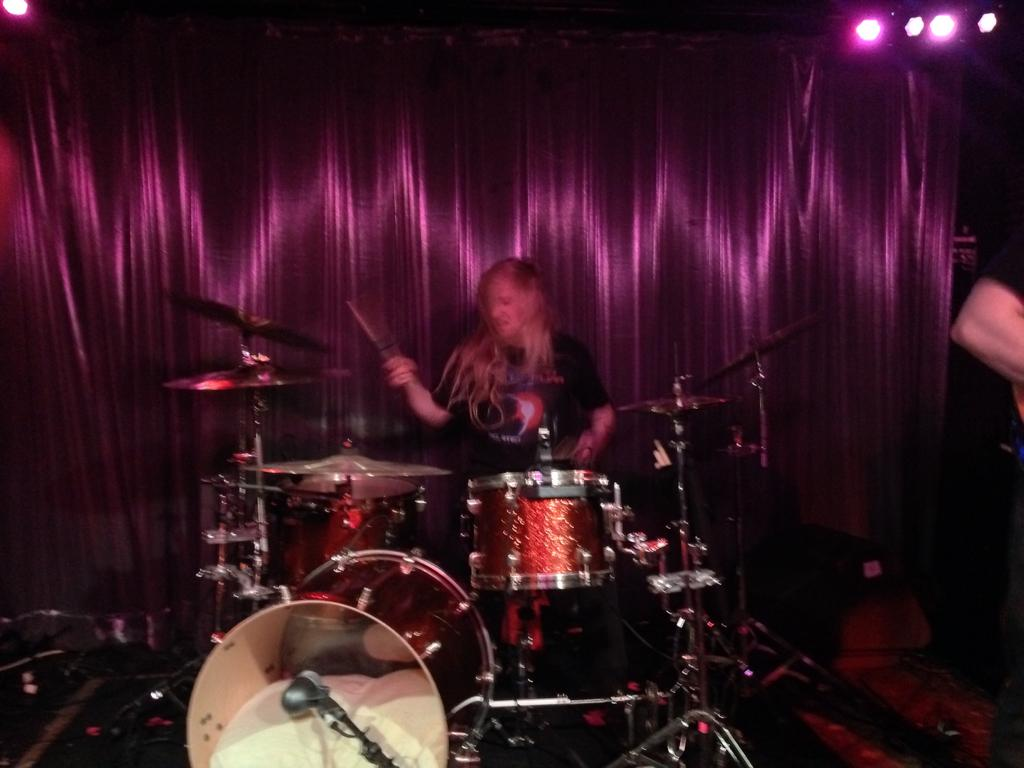What is the main subject of the image? The main subject of the image is a woman. What is the woman doing in the image? The woman is playing musical drums. What can be seen in the background of the image? There is a curtain in the background of the image. What year is depicted in the image? There is no specific year depicted in the image; it is a snapshot of a woman playing musical drums. Can you tell me how many waves are visible in the image? There are no waves present in the image. 